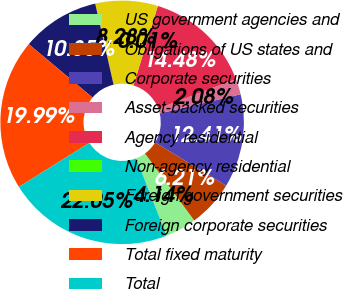Convert chart to OTSL. <chart><loc_0><loc_0><loc_500><loc_500><pie_chart><fcel>US government agencies and<fcel>Obligations of US states and<fcel>Corporate securities<fcel>Asset-backed securities<fcel>Agency residential<fcel>Non-agency residential<fcel>Foreign government securities<fcel>Foreign corporate securities<fcel>Total fixed maturity<fcel>Total<nl><fcel>4.14%<fcel>6.21%<fcel>12.41%<fcel>2.08%<fcel>14.48%<fcel>0.01%<fcel>8.28%<fcel>10.35%<fcel>19.99%<fcel>22.05%<nl></chart> 